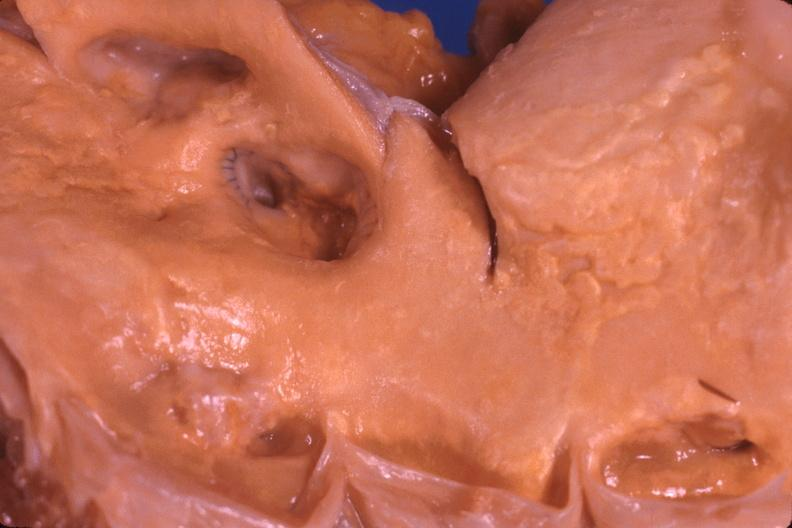where is this?
Answer the question using a single word or phrase. Aorta 